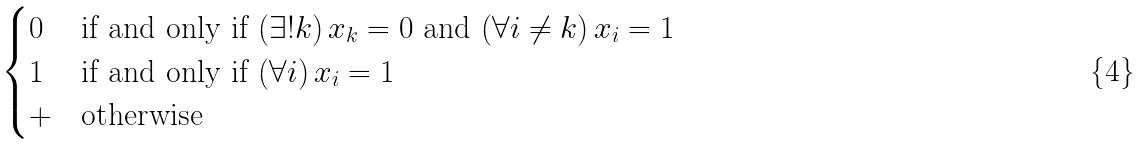Convert formula to latex. <formula><loc_0><loc_0><loc_500><loc_500>\begin{cases} 0 & \text {if and only if } ( \exists ! k ) \, x _ { k } = 0 \text { and } ( \forall i \neq k ) \, x _ { i } = 1 \\ 1 & \text {if and only if } ( \forall i ) \, x _ { i } = 1 \\ + & \text {otherwise} \end{cases}</formula> 